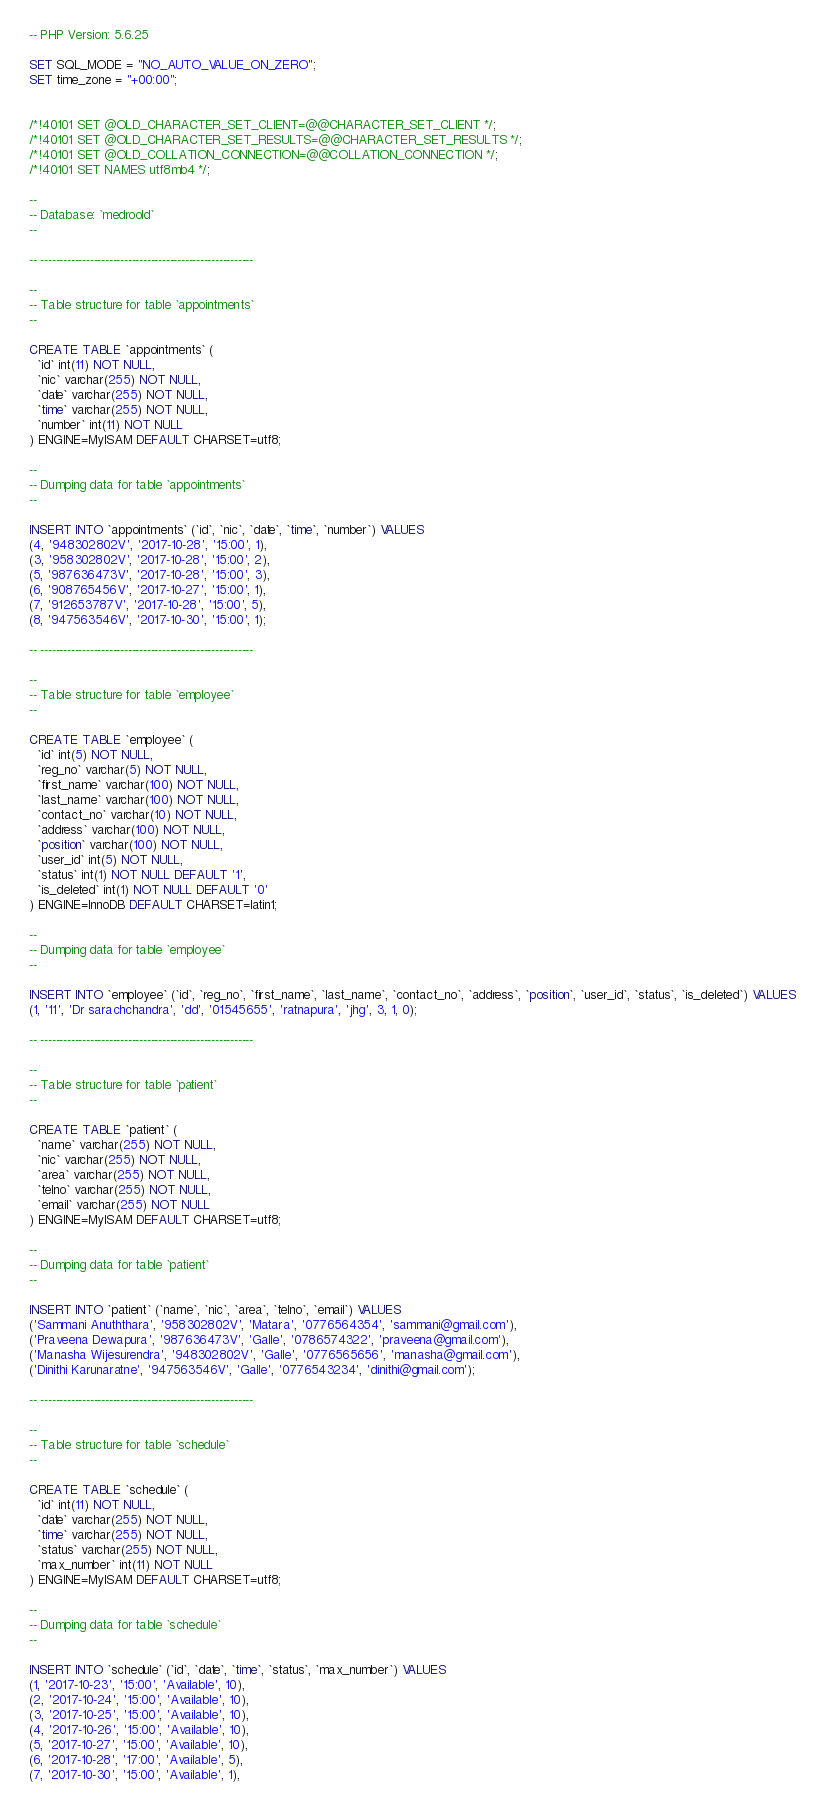<code> <loc_0><loc_0><loc_500><loc_500><_SQL_>-- PHP Version: 5.6.25

SET SQL_MODE = "NO_AUTO_VALUE_ON_ZERO";
SET time_zone = "+00:00";


/*!40101 SET @OLD_CHARACTER_SET_CLIENT=@@CHARACTER_SET_CLIENT */;
/*!40101 SET @OLD_CHARACTER_SET_RESULTS=@@CHARACTER_SET_RESULTS */;
/*!40101 SET @OLD_COLLATION_CONNECTION=@@COLLATION_CONNECTION */;
/*!40101 SET NAMES utf8mb4 */;

--
-- Database: `medroold`
--

-- --------------------------------------------------------

--
-- Table structure for table `appointments`
--

CREATE TABLE `appointments` (
  `id` int(11) NOT NULL,
  `nic` varchar(255) NOT NULL,
  `date` varchar(255) NOT NULL,
  `time` varchar(255) NOT NULL,
  `number` int(11) NOT NULL
) ENGINE=MyISAM DEFAULT CHARSET=utf8;

--
-- Dumping data for table `appointments`
--

INSERT INTO `appointments` (`id`, `nic`, `date`, `time`, `number`) VALUES
(4, '948302802V', '2017-10-28', '15:00', 1),
(3, '958302802V', '2017-10-28', '15:00', 2),
(5, '987636473V', '2017-10-28', '15:00', 3),
(6, '908765456V', '2017-10-27', '15:00', 1),
(7, '912653787V', '2017-10-28', '15:00', 5),
(8, '947563546V', '2017-10-30', '15:00', 1);

-- --------------------------------------------------------

--
-- Table structure for table `employee`
--

CREATE TABLE `employee` (
  `id` int(5) NOT NULL,
  `reg_no` varchar(5) NOT NULL,
  `first_name` varchar(100) NOT NULL,
  `last_name` varchar(100) NOT NULL,
  `contact_no` varchar(10) NOT NULL,
  `address` varchar(100) NOT NULL,
  `position` varchar(100) NOT NULL,
  `user_id` int(5) NOT NULL,
  `status` int(1) NOT NULL DEFAULT '1',
  `is_deleted` int(1) NOT NULL DEFAULT '0'
) ENGINE=InnoDB DEFAULT CHARSET=latin1;

--
-- Dumping data for table `employee`
--

INSERT INTO `employee` (`id`, `reg_no`, `first_name`, `last_name`, `contact_no`, `address`, `position`, `user_id`, `status`, `is_deleted`) VALUES
(1, '11', 'Dr sarachchandra', 'dd', '01545655', 'ratnapura', 'jhg', 3, 1, 0);

-- --------------------------------------------------------

--
-- Table structure for table `patient`
--

CREATE TABLE `patient` (
  `name` varchar(255) NOT NULL,
  `nic` varchar(255) NOT NULL,
  `area` varchar(255) NOT NULL,
  `telno` varchar(255) NOT NULL,
  `email` varchar(255) NOT NULL
) ENGINE=MyISAM DEFAULT CHARSET=utf8;

--
-- Dumping data for table `patient`
--

INSERT INTO `patient` (`name`, `nic`, `area`, `telno`, `email`) VALUES
('Sammani Anuththara', '958302802V', 'Matara', '0776564354', 'sammani@gmail.com'),
('Praveena Dewapura', '987636473V', 'Galle', '0786574322', 'praveena@gmail.com'),
('Manasha Wijesurendra', '948302802V', 'Galle', '0776565656', 'manasha@gmail.com'),
('Dinithi Karunaratne', '947563546V', 'Galle', '0776543234', 'dinithi@gmail.com');

-- --------------------------------------------------------

--
-- Table structure for table `schedule`
--

CREATE TABLE `schedule` (
  `id` int(11) NOT NULL,
  `date` varchar(255) NOT NULL,
  `time` varchar(255) NOT NULL,
  `status` varchar(255) NOT NULL,
  `max_number` int(11) NOT NULL
) ENGINE=MyISAM DEFAULT CHARSET=utf8;

--
-- Dumping data for table `schedule`
--

INSERT INTO `schedule` (`id`, `date`, `time`, `status`, `max_number`) VALUES
(1, '2017-10-23', '15:00', 'Available', 10),
(2, '2017-10-24', '15:00', 'Available', 10),
(3, '2017-10-25', '15:00', 'Available', 10),
(4, '2017-10-26', '15:00', 'Available', 10),
(5, '2017-10-27', '15:00', 'Available', 10),
(6, '2017-10-28', '17:00', 'Available', 5),
(7, '2017-10-30', '15:00', 'Available', 1),</code> 